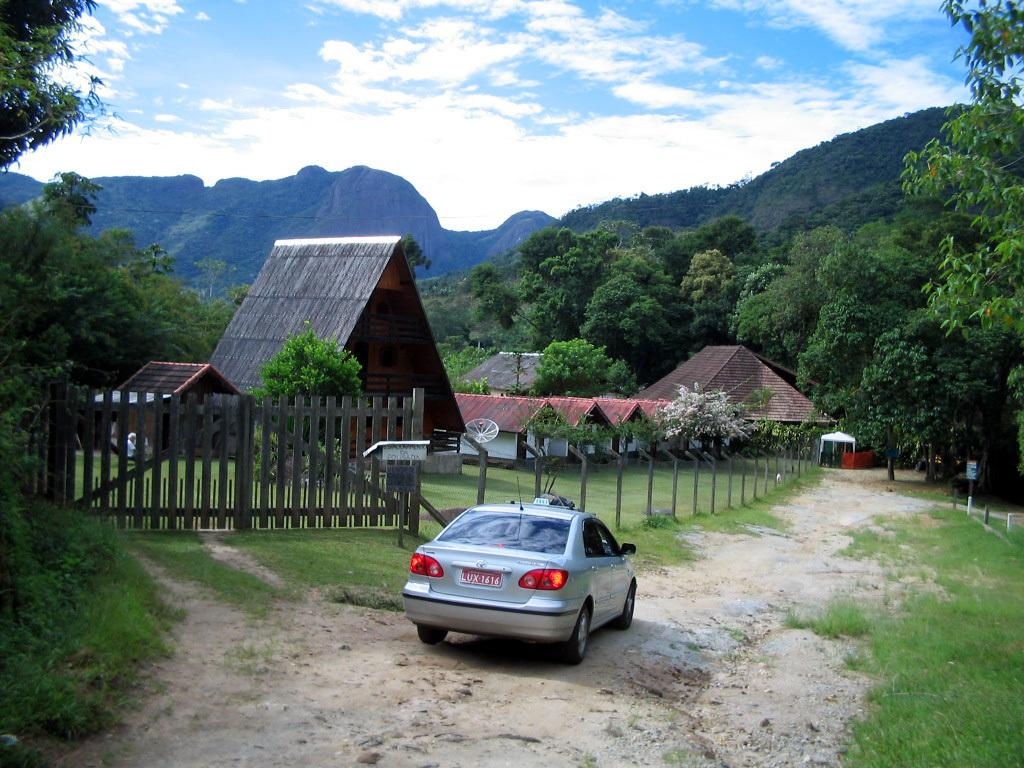What is on the road in the image? There is a vehicle on the road in the image. What type of vegetation can be seen in the image? There is grass visible in the image, as well as trees. What type of barrier is present in the image? There is a fence in the image. What type of structures are visible in the image? There are houses in the image. What type of geographical feature can be seen in the image? There are hills in the image. What is visible in the background of the image? The sky is visible in the background of the image. How many muscles can be seen flexing in the image? There are no muscles visible in the image, as it features a vehicle on the road, grass, a fence, houses, trees, hills, and the sky. 